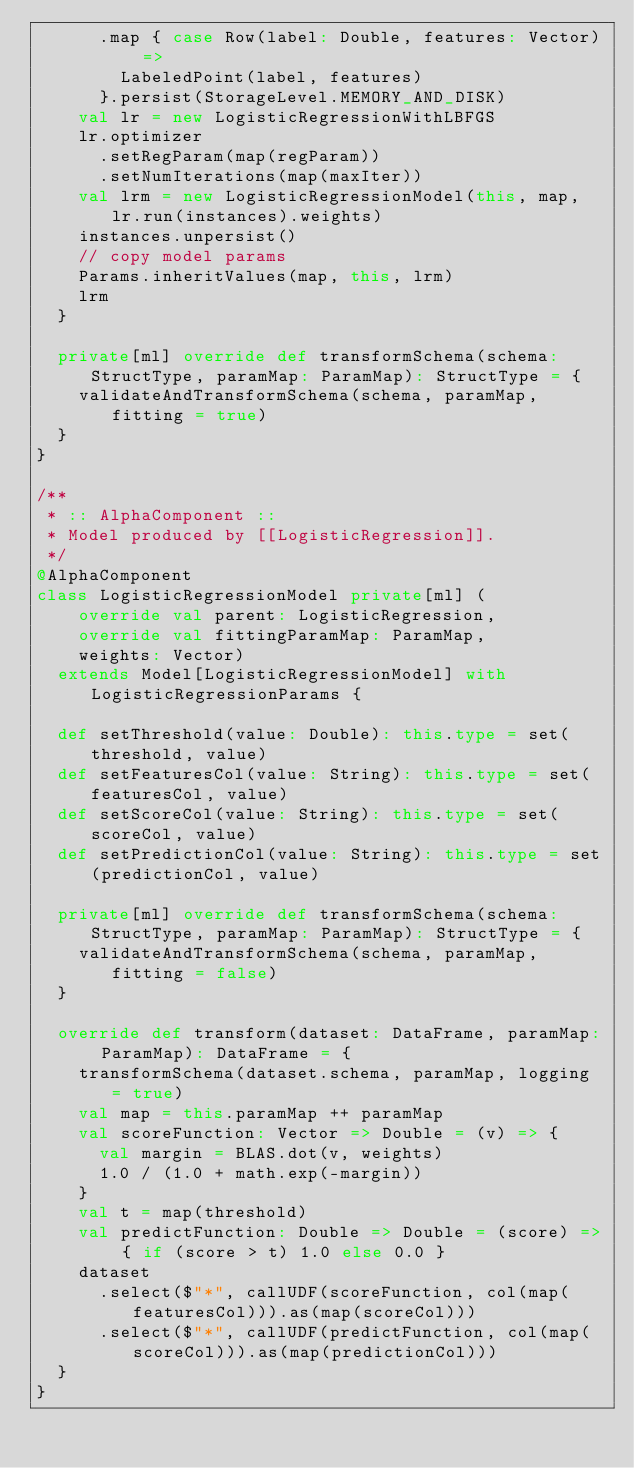<code> <loc_0><loc_0><loc_500><loc_500><_Scala_>      .map { case Row(label: Double, features: Vector) =>
        LabeledPoint(label, features)
      }.persist(StorageLevel.MEMORY_AND_DISK)
    val lr = new LogisticRegressionWithLBFGS
    lr.optimizer
      .setRegParam(map(regParam))
      .setNumIterations(map(maxIter))
    val lrm = new LogisticRegressionModel(this, map, lr.run(instances).weights)
    instances.unpersist()
    // copy model params
    Params.inheritValues(map, this, lrm)
    lrm
  }

  private[ml] override def transformSchema(schema: StructType, paramMap: ParamMap): StructType = {
    validateAndTransformSchema(schema, paramMap, fitting = true)
  }
}

/**
 * :: AlphaComponent ::
 * Model produced by [[LogisticRegression]].
 */
@AlphaComponent
class LogisticRegressionModel private[ml] (
    override val parent: LogisticRegression,
    override val fittingParamMap: ParamMap,
    weights: Vector)
  extends Model[LogisticRegressionModel] with LogisticRegressionParams {

  def setThreshold(value: Double): this.type = set(threshold, value)
  def setFeaturesCol(value: String): this.type = set(featuresCol, value)
  def setScoreCol(value: String): this.type = set(scoreCol, value)
  def setPredictionCol(value: String): this.type = set(predictionCol, value)

  private[ml] override def transformSchema(schema: StructType, paramMap: ParamMap): StructType = {
    validateAndTransformSchema(schema, paramMap, fitting = false)
  }

  override def transform(dataset: DataFrame, paramMap: ParamMap): DataFrame = {
    transformSchema(dataset.schema, paramMap, logging = true)
    val map = this.paramMap ++ paramMap
    val scoreFunction: Vector => Double = (v) => {
      val margin = BLAS.dot(v, weights)
      1.0 / (1.0 + math.exp(-margin))
    }
    val t = map(threshold)
    val predictFunction: Double => Double = (score) => { if (score > t) 1.0 else 0.0 }
    dataset
      .select($"*", callUDF(scoreFunction, col(map(featuresCol))).as(map(scoreCol)))
      .select($"*", callUDF(predictFunction, col(map(scoreCol))).as(map(predictionCol)))
  }
}
</code> 